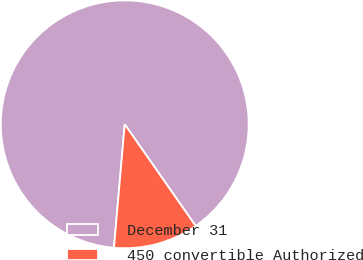Convert chart. <chart><loc_0><loc_0><loc_500><loc_500><pie_chart><fcel>December 31<fcel>450 convertible Authorized<nl><fcel>88.92%<fcel>11.08%<nl></chart> 